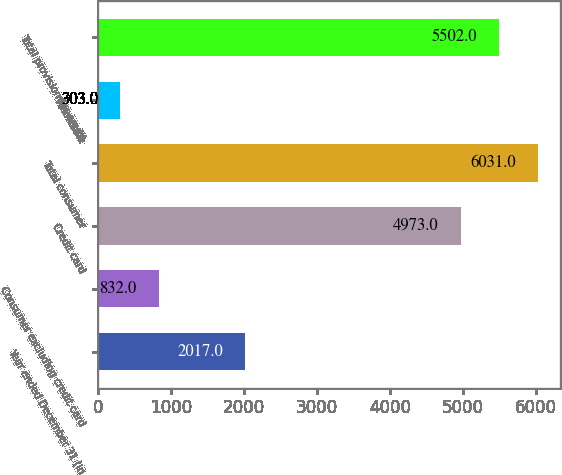Convert chart. <chart><loc_0><loc_0><loc_500><loc_500><bar_chart><fcel>Year ended December 31 (in<fcel>Consumer excluding credit card<fcel>Credit card<fcel>Total consumer<fcel>Wholesale<fcel>Total provision for credit<nl><fcel>2017<fcel>832<fcel>4973<fcel>6031<fcel>303<fcel>5502<nl></chart> 